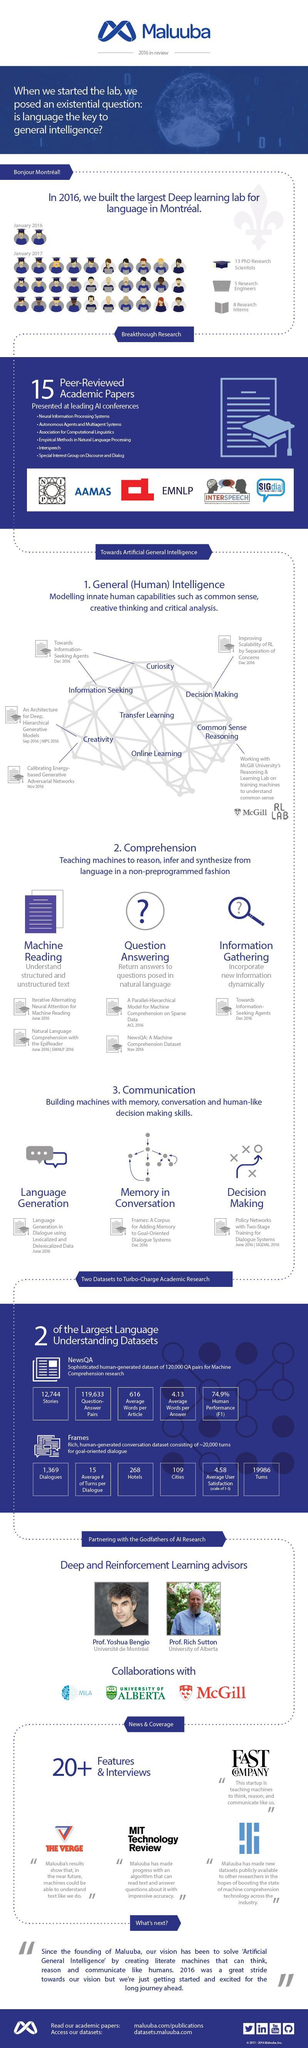What is the average words per article?
Answer the question with a short phrase. 616 What is the number of cities? 109 What is the number of question-answer pairs? 119,633 What is the average words per answer? 4.13 What is the number of stories? 12,744 What is the number of dialogues? 1,369 